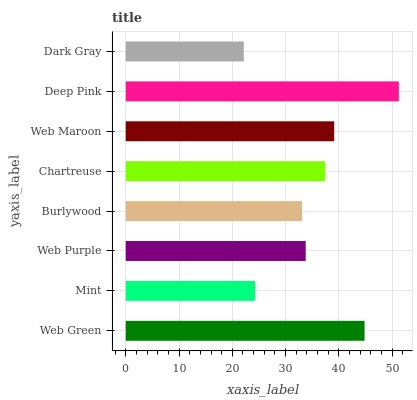Is Dark Gray the minimum?
Answer yes or no. Yes. Is Deep Pink the maximum?
Answer yes or no. Yes. Is Mint the minimum?
Answer yes or no. No. Is Mint the maximum?
Answer yes or no. No. Is Web Green greater than Mint?
Answer yes or no. Yes. Is Mint less than Web Green?
Answer yes or no. Yes. Is Mint greater than Web Green?
Answer yes or no. No. Is Web Green less than Mint?
Answer yes or no. No. Is Chartreuse the high median?
Answer yes or no. Yes. Is Web Purple the low median?
Answer yes or no. Yes. Is Mint the high median?
Answer yes or no. No. Is Dark Gray the low median?
Answer yes or no. No. 